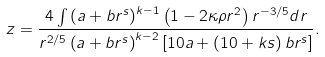<formula> <loc_0><loc_0><loc_500><loc_500>z = \frac { 4 \int \left ( a + b r ^ { s } \right ) ^ { k - 1 } \left ( 1 - 2 \kappa \rho r ^ { 2 } \right ) r ^ { - 3 / 5 } d r } { r ^ { 2 / 5 } \left ( a + b r ^ { s } \right ) ^ { k - 2 } \left [ 1 0 a + \left ( 1 0 + k s \right ) b r ^ { s } \right ] } .</formula> 